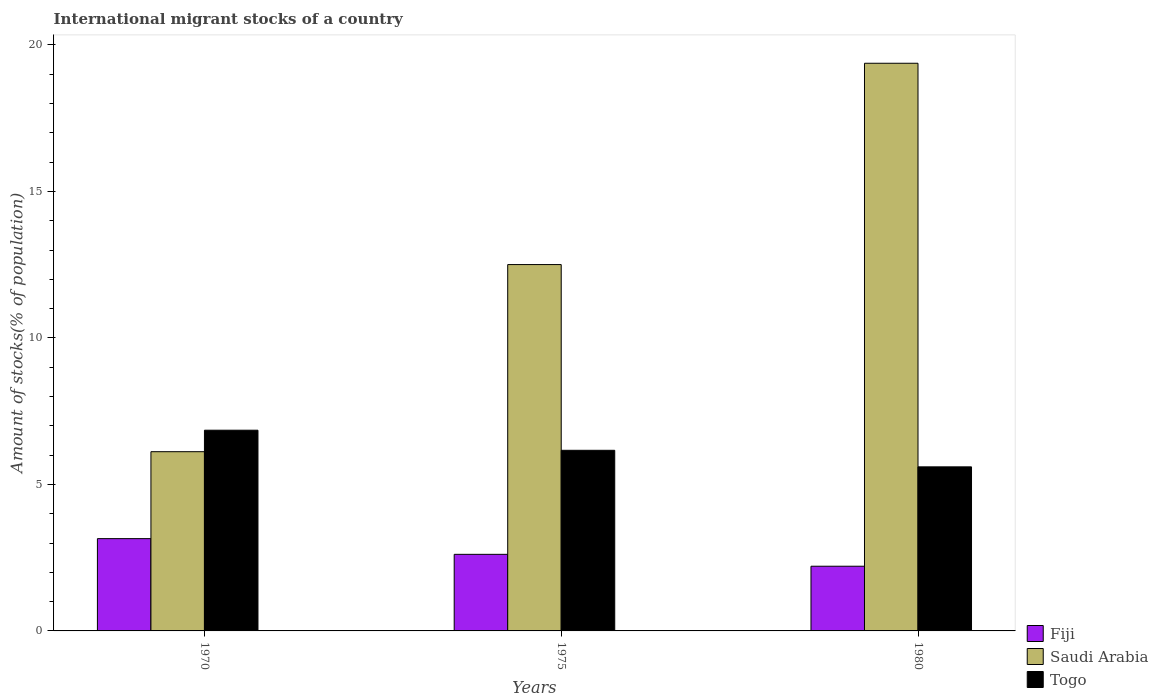How many different coloured bars are there?
Your response must be concise. 3. Are the number of bars per tick equal to the number of legend labels?
Your answer should be very brief. Yes. What is the label of the 2nd group of bars from the left?
Your answer should be compact. 1975. What is the amount of stocks in in Saudi Arabia in 1980?
Offer a very short reply. 19.37. Across all years, what is the maximum amount of stocks in in Fiji?
Offer a very short reply. 3.15. Across all years, what is the minimum amount of stocks in in Saudi Arabia?
Give a very brief answer. 6.12. In which year was the amount of stocks in in Fiji maximum?
Ensure brevity in your answer.  1970. In which year was the amount of stocks in in Fiji minimum?
Your answer should be very brief. 1980. What is the total amount of stocks in in Fiji in the graph?
Ensure brevity in your answer.  7.97. What is the difference between the amount of stocks in in Saudi Arabia in 1970 and that in 1975?
Offer a very short reply. -6.39. What is the difference between the amount of stocks in in Saudi Arabia in 1970 and the amount of stocks in in Togo in 1980?
Offer a terse response. 0.52. What is the average amount of stocks in in Fiji per year?
Offer a terse response. 2.66. In the year 1970, what is the difference between the amount of stocks in in Togo and amount of stocks in in Fiji?
Make the answer very short. 3.7. In how many years, is the amount of stocks in in Togo greater than 16 %?
Offer a terse response. 0. What is the ratio of the amount of stocks in in Togo in 1975 to that in 1980?
Provide a succinct answer. 1.1. What is the difference between the highest and the second highest amount of stocks in in Fiji?
Keep it short and to the point. 0.54. What is the difference between the highest and the lowest amount of stocks in in Togo?
Your answer should be compact. 1.25. Is the sum of the amount of stocks in in Saudi Arabia in 1970 and 1980 greater than the maximum amount of stocks in in Fiji across all years?
Make the answer very short. Yes. What does the 2nd bar from the left in 1970 represents?
Keep it short and to the point. Saudi Arabia. What does the 3rd bar from the right in 1975 represents?
Make the answer very short. Fiji. Is it the case that in every year, the sum of the amount of stocks in in Saudi Arabia and amount of stocks in in Fiji is greater than the amount of stocks in in Togo?
Your answer should be compact. Yes. How many years are there in the graph?
Give a very brief answer. 3. What is the difference between two consecutive major ticks on the Y-axis?
Ensure brevity in your answer.  5. Does the graph contain grids?
Make the answer very short. No. How many legend labels are there?
Ensure brevity in your answer.  3. How are the legend labels stacked?
Offer a very short reply. Vertical. What is the title of the graph?
Ensure brevity in your answer.  International migrant stocks of a country. What is the label or title of the X-axis?
Provide a succinct answer. Years. What is the label or title of the Y-axis?
Keep it short and to the point. Amount of stocks(% of population). What is the Amount of stocks(% of population) in Fiji in 1970?
Ensure brevity in your answer.  3.15. What is the Amount of stocks(% of population) in Saudi Arabia in 1970?
Provide a succinct answer. 6.12. What is the Amount of stocks(% of population) of Togo in 1970?
Offer a very short reply. 6.85. What is the Amount of stocks(% of population) of Fiji in 1975?
Make the answer very short. 2.61. What is the Amount of stocks(% of population) in Saudi Arabia in 1975?
Give a very brief answer. 12.5. What is the Amount of stocks(% of population) in Togo in 1975?
Provide a short and direct response. 6.16. What is the Amount of stocks(% of population) of Fiji in 1980?
Your response must be concise. 2.21. What is the Amount of stocks(% of population) in Saudi Arabia in 1980?
Make the answer very short. 19.37. What is the Amount of stocks(% of population) in Togo in 1980?
Offer a terse response. 5.6. Across all years, what is the maximum Amount of stocks(% of population) in Fiji?
Provide a short and direct response. 3.15. Across all years, what is the maximum Amount of stocks(% of population) in Saudi Arabia?
Make the answer very short. 19.37. Across all years, what is the maximum Amount of stocks(% of population) in Togo?
Offer a terse response. 6.85. Across all years, what is the minimum Amount of stocks(% of population) of Fiji?
Make the answer very short. 2.21. Across all years, what is the minimum Amount of stocks(% of population) of Saudi Arabia?
Make the answer very short. 6.12. Across all years, what is the minimum Amount of stocks(% of population) of Togo?
Provide a succinct answer. 5.6. What is the total Amount of stocks(% of population) of Fiji in the graph?
Your answer should be very brief. 7.97. What is the total Amount of stocks(% of population) of Saudi Arabia in the graph?
Your answer should be very brief. 37.99. What is the total Amount of stocks(% of population) in Togo in the graph?
Provide a short and direct response. 18.61. What is the difference between the Amount of stocks(% of population) of Fiji in 1970 and that in 1975?
Provide a succinct answer. 0.54. What is the difference between the Amount of stocks(% of population) in Saudi Arabia in 1970 and that in 1975?
Your answer should be compact. -6.39. What is the difference between the Amount of stocks(% of population) in Togo in 1970 and that in 1975?
Make the answer very short. 0.69. What is the difference between the Amount of stocks(% of population) of Fiji in 1970 and that in 1980?
Provide a short and direct response. 0.94. What is the difference between the Amount of stocks(% of population) in Saudi Arabia in 1970 and that in 1980?
Your answer should be very brief. -13.26. What is the difference between the Amount of stocks(% of population) of Togo in 1970 and that in 1980?
Offer a terse response. 1.25. What is the difference between the Amount of stocks(% of population) of Fiji in 1975 and that in 1980?
Give a very brief answer. 0.41. What is the difference between the Amount of stocks(% of population) in Saudi Arabia in 1975 and that in 1980?
Make the answer very short. -6.87. What is the difference between the Amount of stocks(% of population) in Togo in 1975 and that in 1980?
Offer a very short reply. 0.56. What is the difference between the Amount of stocks(% of population) in Fiji in 1970 and the Amount of stocks(% of population) in Saudi Arabia in 1975?
Ensure brevity in your answer.  -9.35. What is the difference between the Amount of stocks(% of population) of Fiji in 1970 and the Amount of stocks(% of population) of Togo in 1975?
Offer a very short reply. -3.01. What is the difference between the Amount of stocks(% of population) of Saudi Arabia in 1970 and the Amount of stocks(% of population) of Togo in 1975?
Keep it short and to the point. -0.05. What is the difference between the Amount of stocks(% of population) of Fiji in 1970 and the Amount of stocks(% of population) of Saudi Arabia in 1980?
Provide a short and direct response. -16.22. What is the difference between the Amount of stocks(% of population) in Fiji in 1970 and the Amount of stocks(% of population) in Togo in 1980?
Provide a short and direct response. -2.45. What is the difference between the Amount of stocks(% of population) of Saudi Arabia in 1970 and the Amount of stocks(% of population) of Togo in 1980?
Offer a terse response. 0.52. What is the difference between the Amount of stocks(% of population) in Fiji in 1975 and the Amount of stocks(% of population) in Saudi Arabia in 1980?
Give a very brief answer. -16.76. What is the difference between the Amount of stocks(% of population) of Fiji in 1975 and the Amount of stocks(% of population) of Togo in 1980?
Your response must be concise. -2.99. What is the difference between the Amount of stocks(% of population) in Saudi Arabia in 1975 and the Amount of stocks(% of population) in Togo in 1980?
Make the answer very short. 6.9. What is the average Amount of stocks(% of population) of Fiji per year?
Ensure brevity in your answer.  2.66. What is the average Amount of stocks(% of population) of Saudi Arabia per year?
Provide a succinct answer. 12.66. What is the average Amount of stocks(% of population) in Togo per year?
Keep it short and to the point. 6.2. In the year 1970, what is the difference between the Amount of stocks(% of population) in Fiji and Amount of stocks(% of population) in Saudi Arabia?
Give a very brief answer. -2.97. In the year 1970, what is the difference between the Amount of stocks(% of population) of Fiji and Amount of stocks(% of population) of Togo?
Provide a succinct answer. -3.7. In the year 1970, what is the difference between the Amount of stocks(% of population) in Saudi Arabia and Amount of stocks(% of population) in Togo?
Provide a short and direct response. -0.73. In the year 1975, what is the difference between the Amount of stocks(% of population) in Fiji and Amount of stocks(% of population) in Saudi Arabia?
Keep it short and to the point. -9.89. In the year 1975, what is the difference between the Amount of stocks(% of population) of Fiji and Amount of stocks(% of population) of Togo?
Your answer should be very brief. -3.55. In the year 1975, what is the difference between the Amount of stocks(% of population) in Saudi Arabia and Amount of stocks(% of population) in Togo?
Offer a very short reply. 6.34. In the year 1980, what is the difference between the Amount of stocks(% of population) of Fiji and Amount of stocks(% of population) of Saudi Arabia?
Make the answer very short. -17.17. In the year 1980, what is the difference between the Amount of stocks(% of population) in Fiji and Amount of stocks(% of population) in Togo?
Your answer should be very brief. -3.39. In the year 1980, what is the difference between the Amount of stocks(% of population) of Saudi Arabia and Amount of stocks(% of population) of Togo?
Your response must be concise. 13.77. What is the ratio of the Amount of stocks(% of population) of Fiji in 1970 to that in 1975?
Offer a terse response. 1.2. What is the ratio of the Amount of stocks(% of population) of Saudi Arabia in 1970 to that in 1975?
Your answer should be compact. 0.49. What is the ratio of the Amount of stocks(% of population) of Togo in 1970 to that in 1975?
Make the answer very short. 1.11. What is the ratio of the Amount of stocks(% of population) in Fiji in 1970 to that in 1980?
Your answer should be very brief. 1.43. What is the ratio of the Amount of stocks(% of population) in Saudi Arabia in 1970 to that in 1980?
Your answer should be compact. 0.32. What is the ratio of the Amount of stocks(% of population) in Togo in 1970 to that in 1980?
Your answer should be very brief. 1.22. What is the ratio of the Amount of stocks(% of population) of Fiji in 1975 to that in 1980?
Your answer should be very brief. 1.18. What is the ratio of the Amount of stocks(% of population) in Saudi Arabia in 1975 to that in 1980?
Keep it short and to the point. 0.65. What is the ratio of the Amount of stocks(% of population) of Togo in 1975 to that in 1980?
Your answer should be very brief. 1.1. What is the difference between the highest and the second highest Amount of stocks(% of population) of Fiji?
Offer a terse response. 0.54. What is the difference between the highest and the second highest Amount of stocks(% of population) of Saudi Arabia?
Make the answer very short. 6.87. What is the difference between the highest and the second highest Amount of stocks(% of population) in Togo?
Make the answer very short. 0.69. What is the difference between the highest and the lowest Amount of stocks(% of population) in Fiji?
Your answer should be compact. 0.94. What is the difference between the highest and the lowest Amount of stocks(% of population) of Saudi Arabia?
Your answer should be compact. 13.26. What is the difference between the highest and the lowest Amount of stocks(% of population) in Togo?
Offer a terse response. 1.25. 